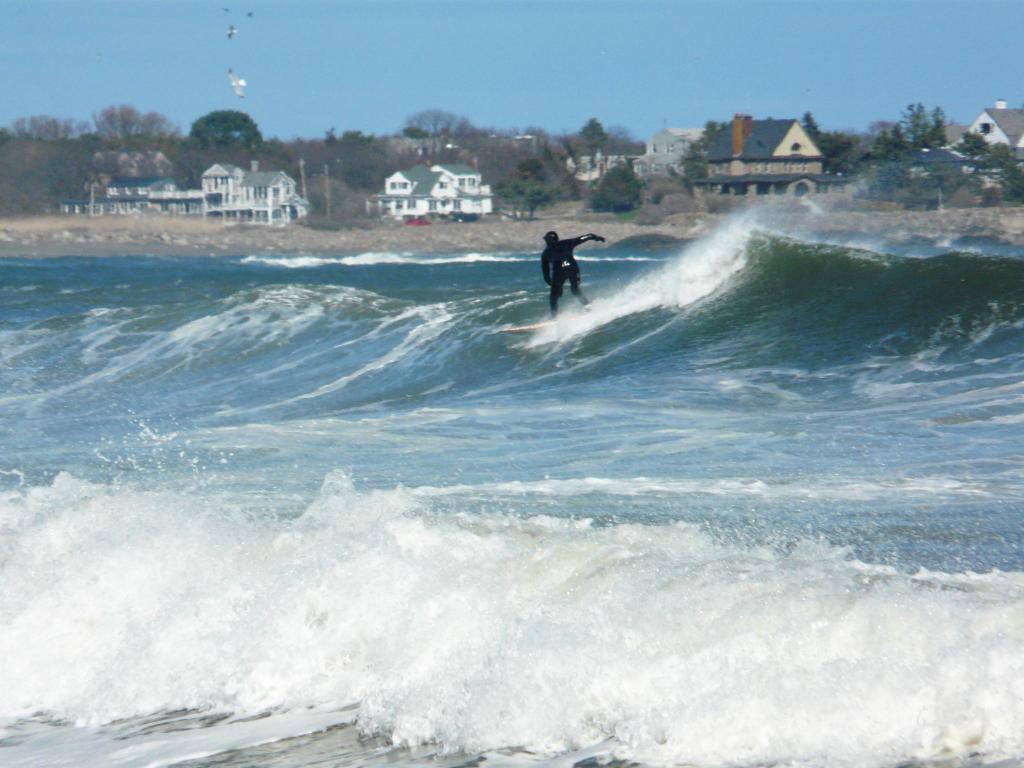What is the main subject of the image? There is a man in the image. What is the man wearing? The man is wearing a black dress. What activity is the man engaged in? The man is surfing. What type of environment is visible in the image? There is water at the bottom of the image, which appears to be an ocean. What can be seen in the background of the image? There are houses and trees in the background of the image. What type of whistle can be heard in the image? There is no whistle present in the image, and therefore no sound can be heard. Can you describe the song that the man is singing while surfing? There is no indication in the image that the man is singing, so it cannot be determined from the picture. 